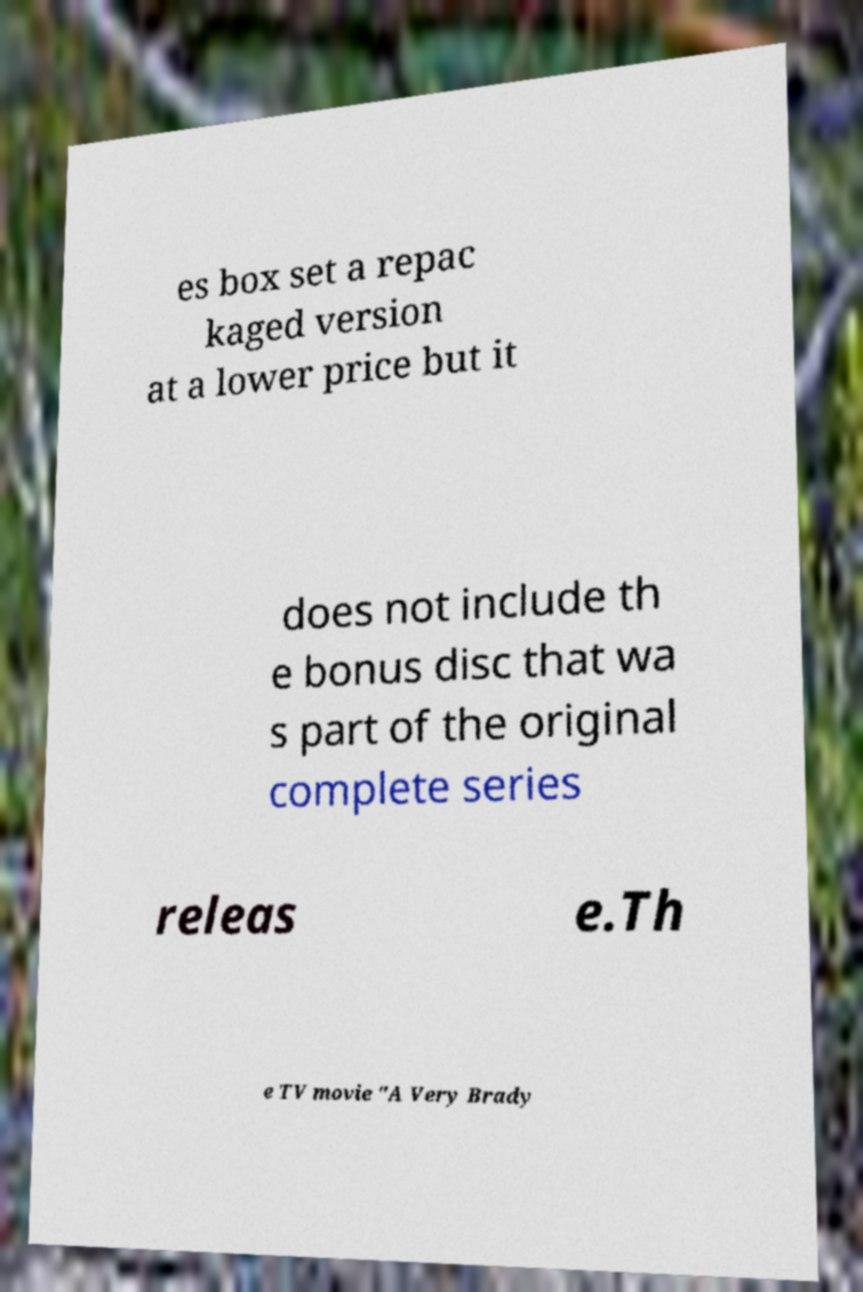Can you read and provide the text displayed in the image?This photo seems to have some interesting text. Can you extract and type it out for me? es box set a repac kaged version at a lower price but it does not include th e bonus disc that wa s part of the original complete series releas e.Th e TV movie "A Very Brady 